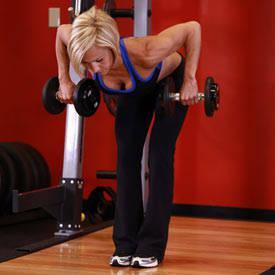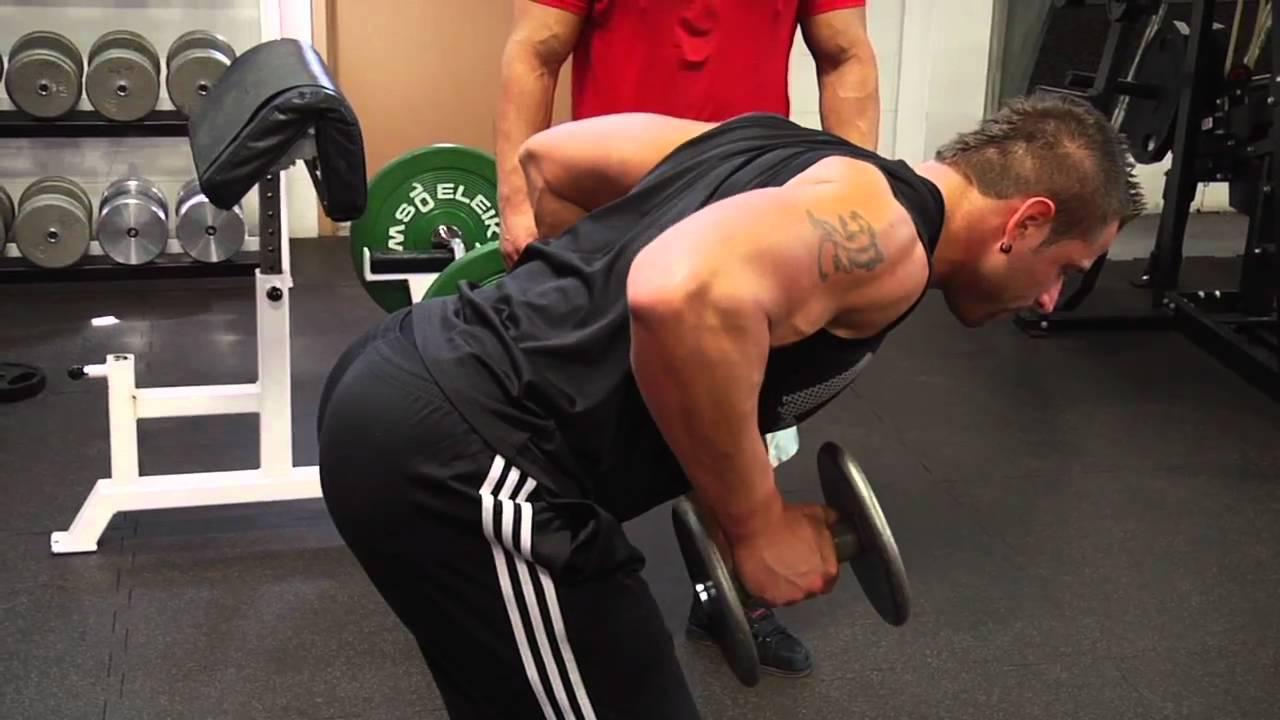The first image is the image on the left, the second image is the image on the right. Evaluate the accuracy of this statement regarding the images: "There is no less than one woman lifting weights". Is it true? Answer yes or no. Yes. The first image is the image on the left, the second image is the image on the right. For the images displayed, is the sentence "An image shows a woman bending forward while holding dumbell weights." factually correct? Answer yes or no. Yes. 